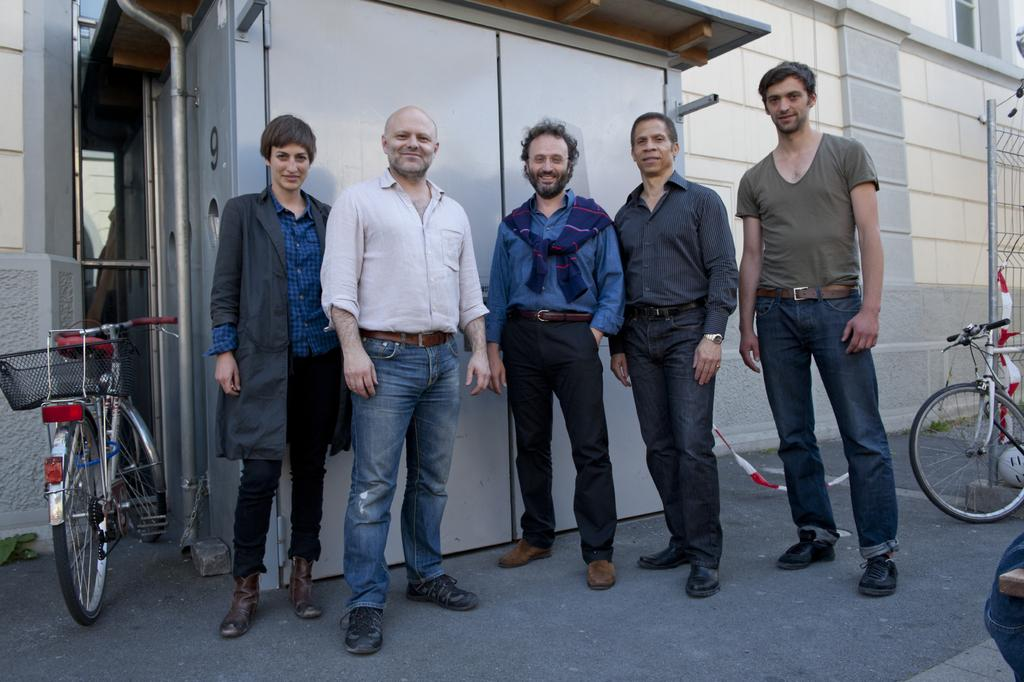What can be seen in the front of the image? There are people and bicycles in the front of the image. What is visible in the background of the image? There is a wall, a shed, a window, and rods in the background of the image. Can you describe the objects in the background of the image? There are objects in the background of the image, but their specific nature is not mentioned in the facts. What type of robin is perched on the window in the image? There is no robin present in the image; the window is mentioned as part of the background objects. What direction is the sun shining from in the image? The facts provided do not mention the sun or its position in the image. 